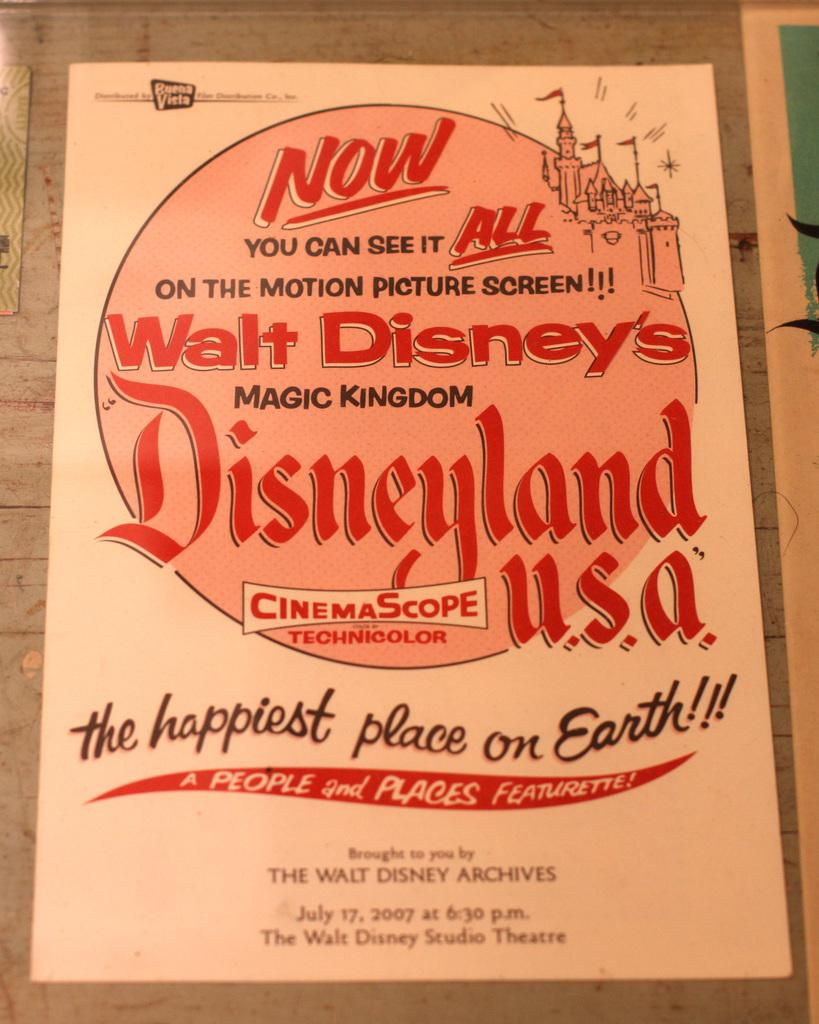What is present on the poster in the image? There is a poster in the image. What can be seen on the poster besides the poster itself? There is writing on the poster in multiple places. What type of ornament is hanging from the poster in the image? There is no ornament hanging from the poster in the image. What historical event is depicted on the poster in the image? The image does not provide any information about historical events or any other content on the poster. 